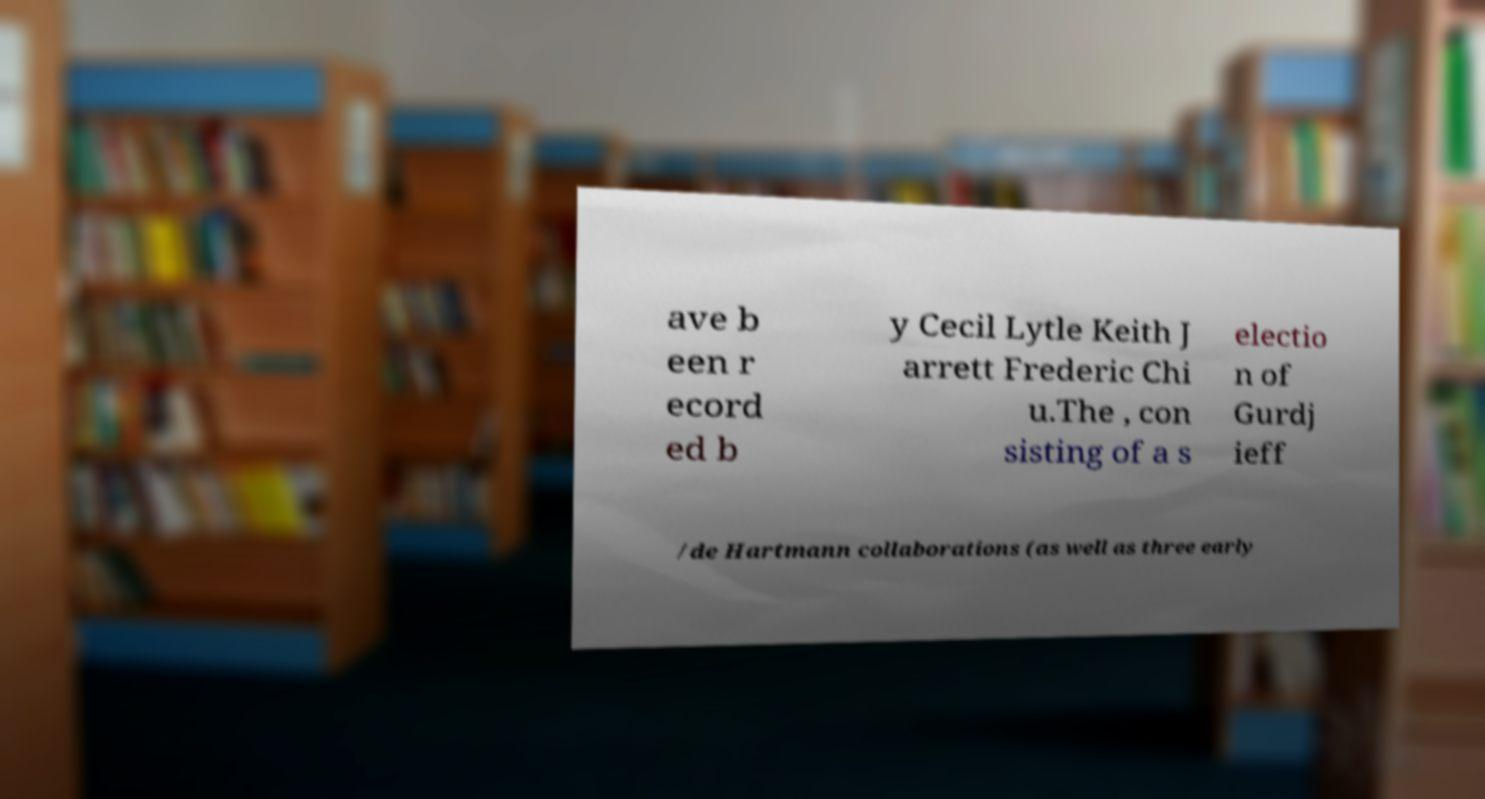Could you assist in decoding the text presented in this image and type it out clearly? ave b een r ecord ed b y Cecil Lytle Keith J arrett Frederic Chi u.The , con sisting of a s electio n of Gurdj ieff /de Hartmann collaborations (as well as three early 